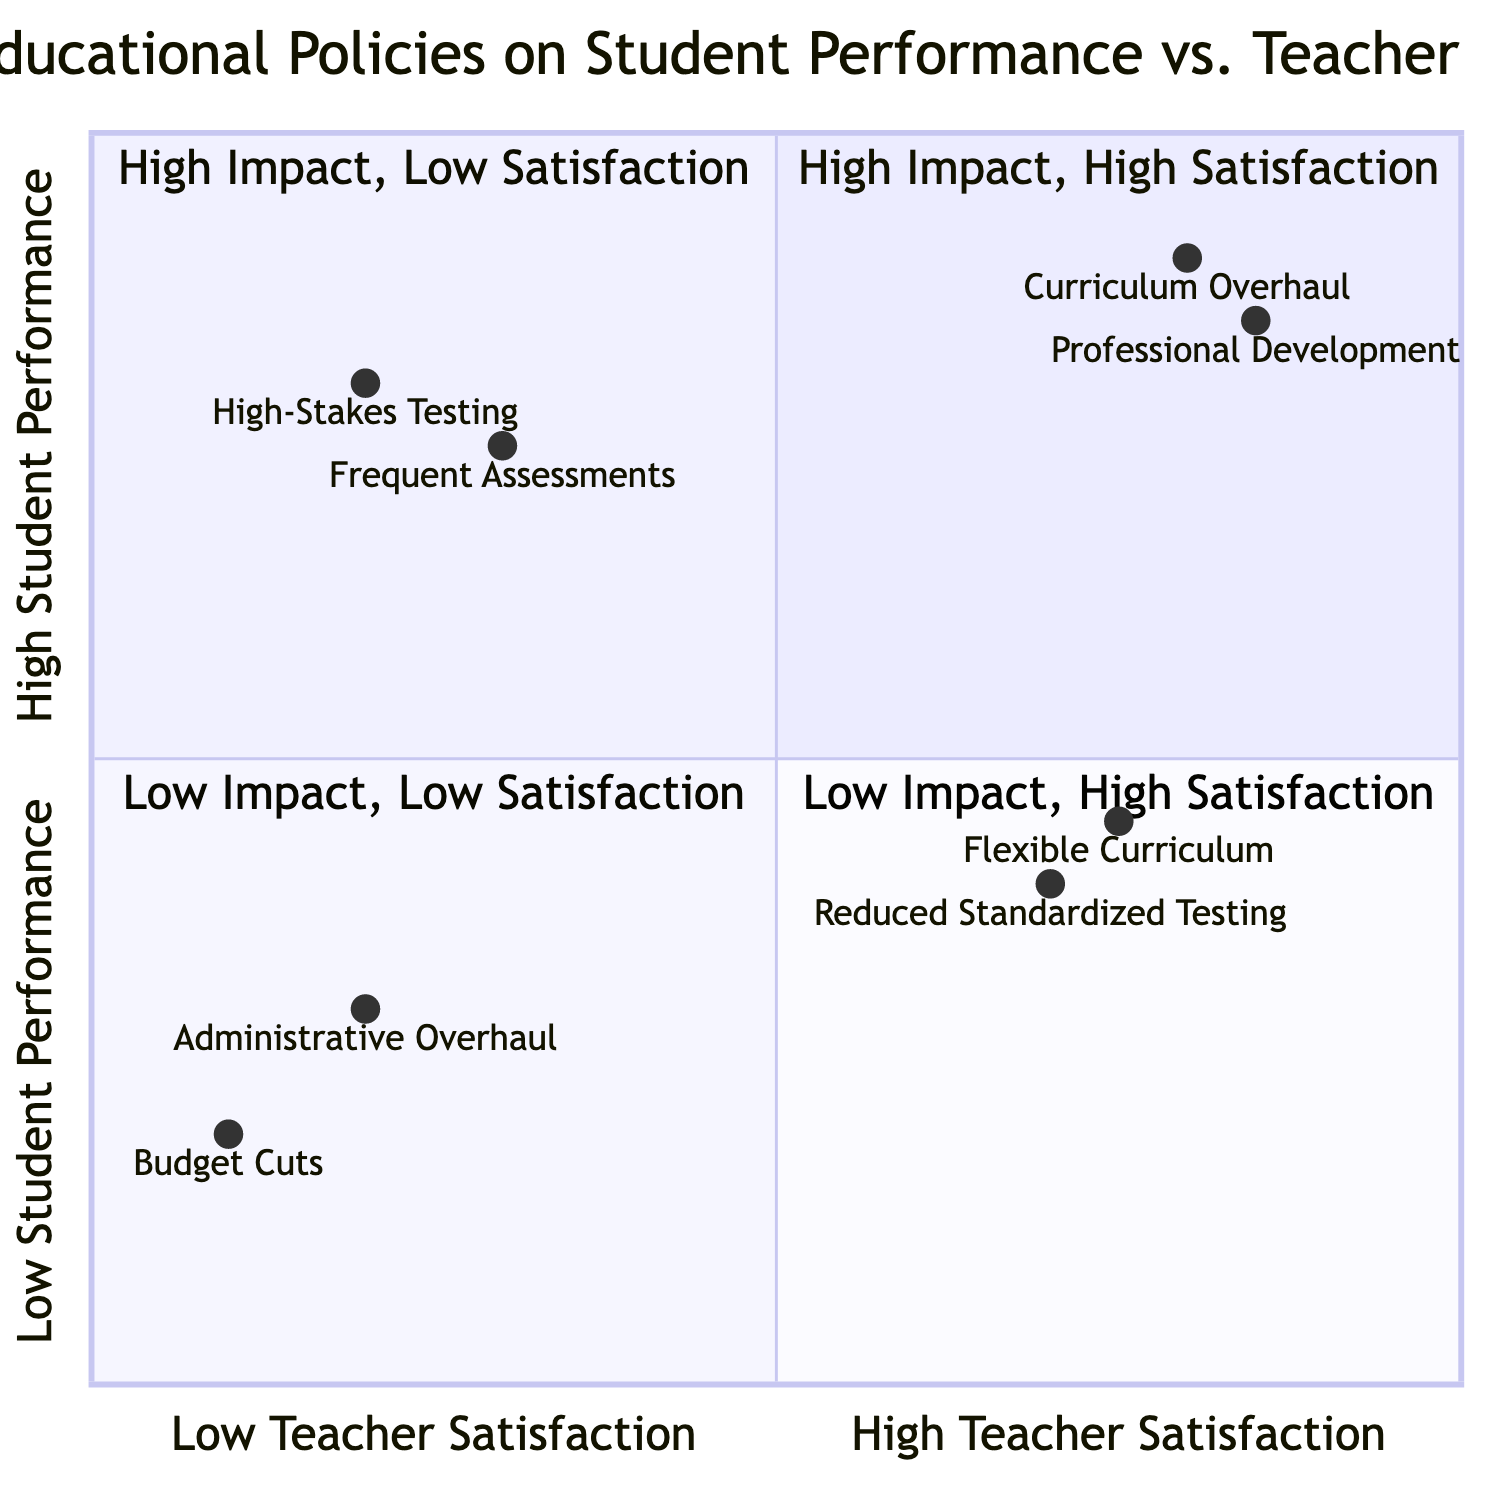What are the elements in the "High Impact on Student Performance, High Teacher Satisfaction" quadrant? This quadrant contains two elements: "Curriculum Overhaul" and "Professional Development." These policies show a high impact on student performance while also ensuring high satisfaction for teachers.
Answer: Curriculum Overhaul, Professional Development What impact does "High-Stakes Testing" have on student performance? "High-Stakes Testing" is positioned in the "High Impact on Student Performance, Low Teacher Satisfaction" quadrant, indicating that it has an impact of "Enhanced academic rigor and accountability" on student performance.
Answer: Enhanced academic rigor and accountability How many elements are in the "Low Impact on Student Performance, Low Teacher Satisfaction" quadrant? This quadrant contains two elements: "Administrative Overhaul" and "Budget Cuts." Both showcase low impact on student performance and low teacher satisfaction.
Answer: 2 Which policy type has the highest teacher satisfaction rating? "Professional Development" is in the "High Impact on Student Performance, High Teacher Satisfaction" quadrant and has a teacher satisfaction factor of "Access to career growth opportunities," indicating a high level of satisfaction.
Answer: Access to career growth opportunities What is the common factor for elements in the "Low Impact on Student Performance, High Teacher Satisfaction" quadrant? Both "Reduced Standardized Testing" and "Flexible Curriculum" policies have shown "Marginal improvement in critical thinking skills" and "Moderate improvement in creativity and well-being," which reflects their similar lower impact on student performance but high teacher satisfaction.
Answer: Marginal improvement in critical thinking skills, Moderate improvement in creativity and well-being Which policy has the lowest impact on student performance? "Budget Cuts" is in the "Low Impact on Student Performance, Low Teacher Satisfaction" quadrant and is associated with "Negative or stagnant student outcomes," making it the policy with the lowest impact on student performance.
Answer: Negative or stagnant student outcomes What is the range of teacher satisfaction values for the policies in the "High Impact, Low Satisfaction" quadrant? The policies "High-Stakes Testing" and "Frequent Assessments" have satisfaction factors of "Increased stress and workload for teachers" and "Time constraints on teaching flexibility," indicating dissatisfaction. The values suggest a range of around 0.2 to 0.3 on the satisfaction axis.
Answer: 0.2 to 0.3 Which quadrant contains policies that lead to a high satisfaction for teachers despite low student performance impact? The "Low Impact on Student Performance, High Teacher Satisfaction" quadrant contains policies that achieve this, specifically "Reduced Standardized Testing" and "Flexible Curriculum." These policies provide greater autonomy for teachers while mitigating pressure.
Answer: Low Impact on Student Performance, High Teacher Satisfaction What example of a policy demonstrates high impact on performance but low satisfaction? The example of "High-Stakes Testing" fits this description, categorized under "High Impact on Student Performance, Low Teacher Satisfaction," illustrating the tension between accountability and teacher well-being.
Answer: High-Stakes Testing 